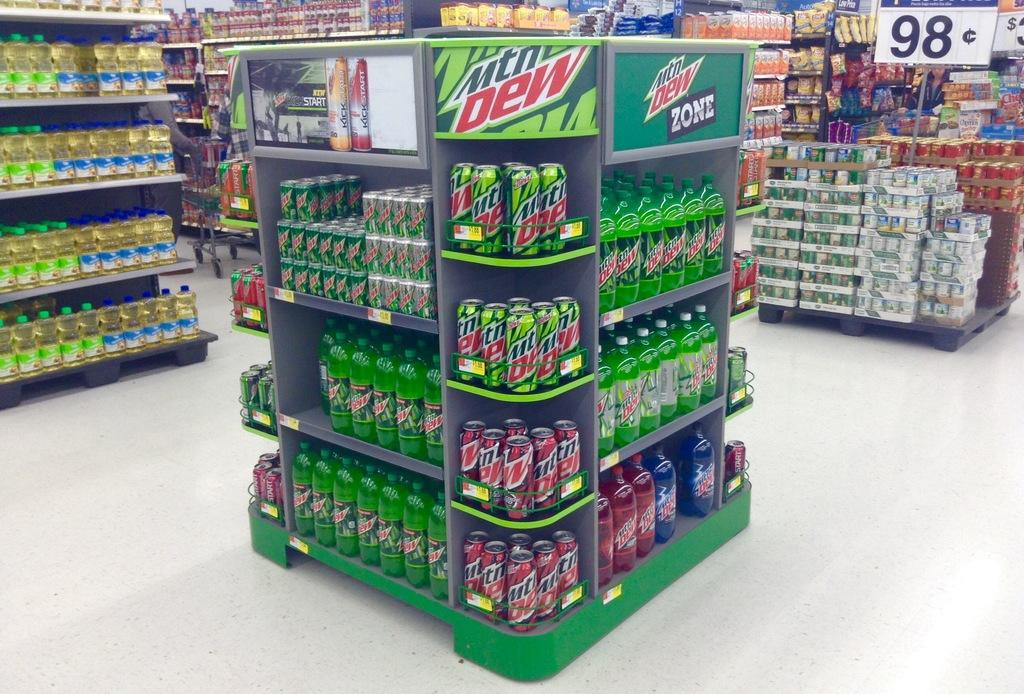<image>
Provide a brief description of the given image. In a grocery store there is a display for mountain dew. 